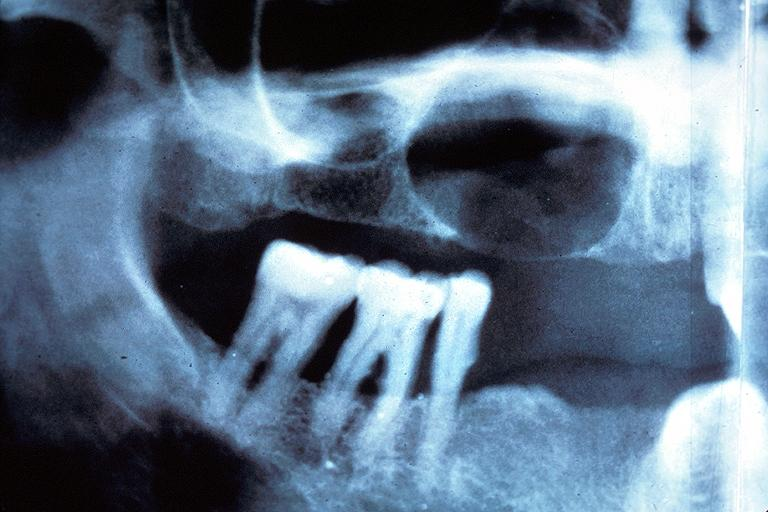what is present?
Answer the question using a single word or phrase. Oral 